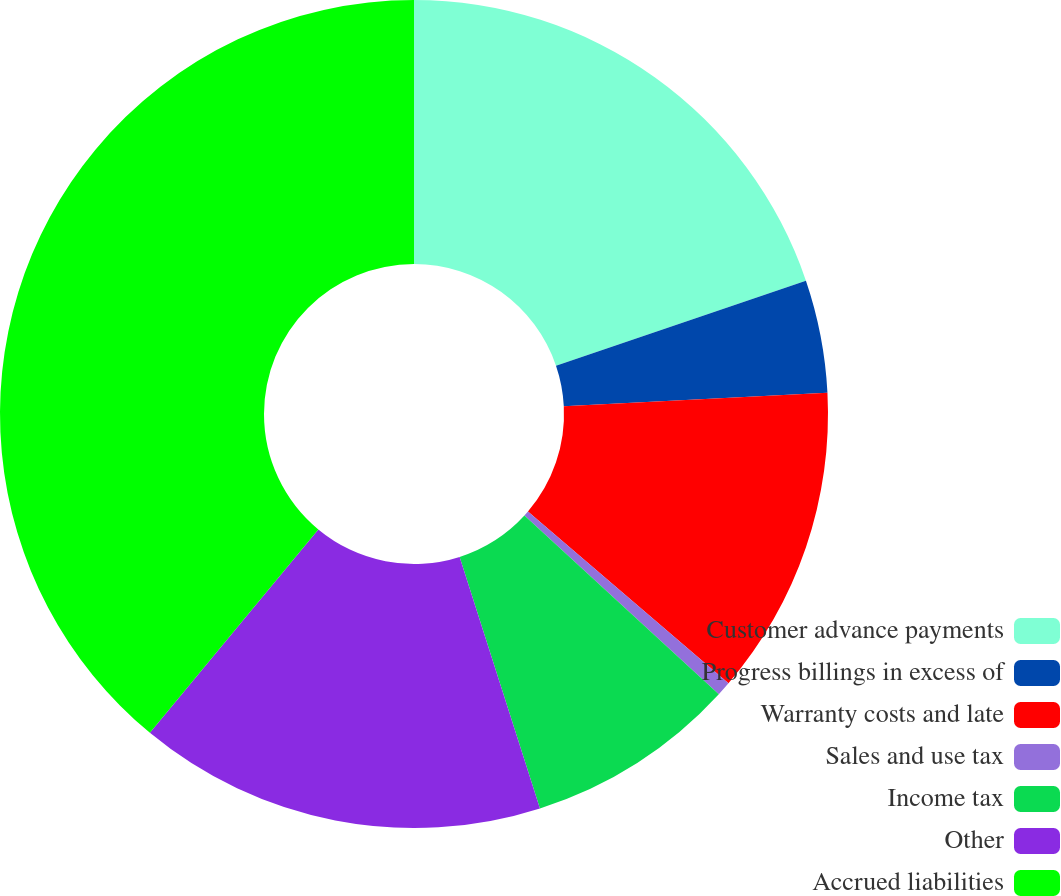Convert chart to OTSL. <chart><loc_0><loc_0><loc_500><loc_500><pie_chart><fcel>Customer advance payments<fcel>Progress billings in excess of<fcel>Warranty costs and late<fcel>Sales and use tax<fcel>Income tax<fcel>Other<fcel>Accrued liabilities<nl><fcel>19.78%<fcel>4.4%<fcel>12.09%<fcel>0.56%<fcel>8.25%<fcel>15.93%<fcel>38.99%<nl></chart> 